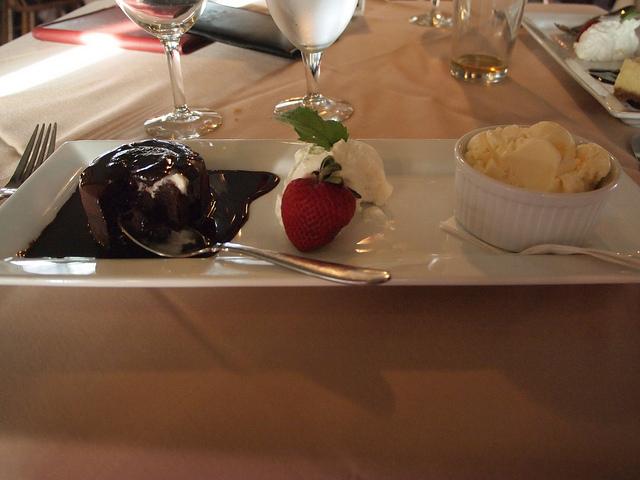How many ice cream bowls?
Short answer required. 1. Do you see a strawberry fruit?
Short answer required. Yes. What course is being served?
Write a very short answer. Dessert. 